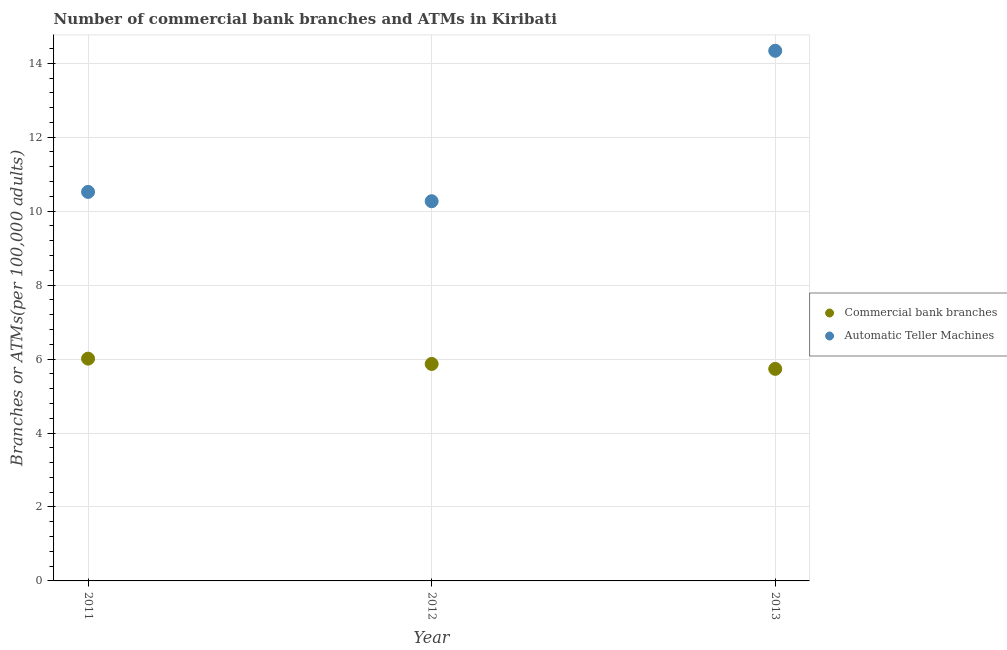What is the number of atms in 2013?
Offer a terse response. 14.34. Across all years, what is the maximum number of commercal bank branches?
Offer a terse response. 6.01. Across all years, what is the minimum number of commercal bank branches?
Offer a very short reply. 5.73. What is the total number of commercal bank branches in the graph?
Give a very brief answer. 17.61. What is the difference between the number of commercal bank branches in 2011 and that in 2012?
Offer a very short reply. 0.14. What is the difference between the number of atms in 2011 and the number of commercal bank branches in 2012?
Make the answer very short. 4.65. What is the average number of atms per year?
Offer a terse response. 11.71. In the year 2011, what is the difference between the number of commercal bank branches and number of atms?
Keep it short and to the point. -4.51. What is the ratio of the number of commercal bank branches in 2012 to that in 2013?
Offer a terse response. 1.02. Is the number of atms in 2012 less than that in 2013?
Provide a succinct answer. Yes. Is the difference between the number of commercal bank branches in 2011 and 2012 greater than the difference between the number of atms in 2011 and 2012?
Your response must be concise. No. What is the difference between the highest and the second highest number of atms?
Make the answer very short. 3.82. What is the difference between the highest and the lowest number of commercal bank branches?
Provide a succinct answer. 0.28. Is the number of atms strictly less than the number of commercal bank branches over the years?
Provide a short and direct response. No. How many years are there in the graph?
Provide a short and direct response. 3. What is the difference between two consecutive major ticks on the Y-axis?
Your answer should be compact. 2. Does the graph contain any zero values?
Ensure brevity in your answer.  No. How many legend labels are there?
Give a very brief answer. 2. How are the legend labels stacked?
Make the answer very short. Vertical. What is the title of the graph?
Your answer should be very brief. Number of commercial bank branches and ATMs in Kiribati. Does "Not attending school" appear as one of the legend labels in the graph?
Make the answer very short. No. What is the label or title of the Y-axis?
Your answer should be very brief. Branches or ATMs(per 100,0 adults). What is the Branches or ATMs(per 100,000 adults) of Commercial bank branches in 2011?
Your response must be concise. 6.01. What is the Branches or ATMs(per 100,000 adults) in Automatic Teller Machines in 2011?
Provide a short and direct response. 10.52. What is the Branches or ATMs(per 100,000 adults) of Commercial bank branches in 2012?
Offer a terse response. 5.87. What is the Branches or ATMs(per 100,000 adults) in Automatic Teller Machines in 2012?
Your response must be concise. 10.27. What is the Branches or ATMs(per 100,000 adults) of Commercial bank branches in 2013?
Your answer should be very brief. 5.73. What is the Branches or ATMs(per 100,000 adults) of Automatic Teller Machines in 2013?
Your answer should be compact. 14.34. Across all years, what is the maximum Branches or ATMs(per 100,000 adults) of Commercial bank branches?
Provide a short and direct response. 6.01. Across all years, what is the maximum Branches or ATMs(per 100,000 adults) in Automatic Teller Machines?
Your answer should be very brief. 14.34. Across all years, what is the minimum Branches or ATMs(per 100,000 adults) of Commercial bank branches?
Make the answer very short. 5.73. Across all years, what is the minimum Branches or ATMs(per 100,000 adults) in Automatic Teller Machines?
Make the answer very short. 10.27. What is the total Branches or ATMs(per 100,000 adults) of Commercial bank branches in the graph?
Ensure brevity in your answer.  17.61. What is the total Branches or ATMs(per 100,000 adults) in Automatic Teller Machines in the graph?
Give a very brief answer. 35.13. What is the difference between the Branches or ATMs(per 100,000 adults) of Commercial bank branches in 2011 and that in 2012?
Make the answer very short. 0.14. What is the difference between the Branches or ATMs(per 100,000 adults) of Automatic Teller Machines in 2011 and that in 2012?
Your response must be concise. 0.25. What is the difference between the Branches or ATMs(per 100,000 adults) of Commercial bank branches in 2011 and that in 2013?
Provide a succinct answer. 0.28. What is the difference between the Branches or ATMs(per 100,000 adults) in Automatic Teller Machines in 2011 and that in 2013?
Ensure brevity in your answer.  -3.82. What is the difference between the Branches or ATMs(per 100,000 adults) of Commercial bank branches in 2012 and that in 2013?
Your answer should be compact. 0.13. What is the difference between the Branches or ATMs(per 100,000 adults) of Automatic Teller Machines in 2012 and that in 2013?
Keep it short and to the point. -4.07. What is the difference between the Branches or ATMs(per 100,000 adults) of Commercial bank branches in 2011 and the Branches or ATMs(per 100,000 adults) of Automatic Teller Machines in 2012?
Keep it short and to the point. -4.26. What is the difference between the Branches or ATMs(per 100,000 adults) in Commercial bank branches in 2011 and the Branches or ATMs(per 100,000 adults) in Automatic Teller Machines in 2013?
Offer a very short reply. -8.33. What is the difference between the Branches or ATMs(per 100,000 adults) in Commercial bank branches in 2012 and the Branches or ATMs(per 100,000 adults) in Automatic Teller Machines in 2013?
Provide a short and direct response. -8.47. What is the average Branches or ATMs(per 100,000 adults) of Commercial bank branches per year?
Keep it short and to the point. 5.87. What is the average Branches or ATMs(per 100,000 adults) in Automatic Teller Machines per year?
Give a very brief answer. 11.71. In the year 2011, what is the difference between the Branches or ATMs(per 100,000 adults) in Commercial bank branches and Branches or ATMs(per 100,000 adults) in Automatic Teller Machines?
Make the answer very short. -4.51. In the year 2012, what is the difference between the Branches or ATMs(per 100,000 adults) of Commercial bank branches and Branches or ATMs(per 100,000 adults) of Automatic Teller Machines?
Make the answer very short. -4.4. In the year 2013, what is the difference between the Branches or ATMs(per 100,000 adults) in Commercial bank branches and Branches or ATMs(per 100,000 adults) in Automatic Teller Machines?
Keep it short and to the point. -8.6. What is the ratio of the Branches or ATMs(per 100,000 adults) in Commercial bank branches in 2011 to that in 2012?
Provide a succinct answer. 1.02. What is the ratio of the Branches or ATMs(per 100,000 adults) in Automatic Teller Machines in 2011 to that in 2012?
Keep it short and to the point. 1.02. What is the ratio of the Branches or ATMs(per 100,000 adults) of Commercial bank branches in 2011 to that in 2013?
Ensure brevity in your answer.  1.05. What is the ratio of the Branches or ATMs(per 100,000 adults) of Automatic Teller Machines in 2011 to that in 2013?
Your answer should be compact. 0.73. What is the ratio of the Branches or ATMs(per 100,000 adults) in Commercial bank branches in 2012 to that in 2013?
Keep it short and to the point. 1.02. What is the ratio of the Branches or ATMs(per 100,000 adults) in Automatic Teller Machines in 2012 to that in 2013?
Your answer should be compact. 0.72. What is the difference between the highest and the second highest Branches or ATMs(per 100,000 adults) of Commercial bank branches?
Provide a succinct answer. 0.14. What is the difference between the highest and the second highest Branches or ATMs(per 100,000 adults) of Automatic Teller Machines?
Make the answer very short. 3.82. What is the difference between the highest and the lowest Branches or ATMs(per 100,000 adults) in Commercial bank branches?
Ensure brevity in your answer.  0.28. What is the difference between the highest and the lowest Branches or ATMs(per 100,000 adults) in Automatic Teller Machines?
Provide a short and direct response. 4.07. 